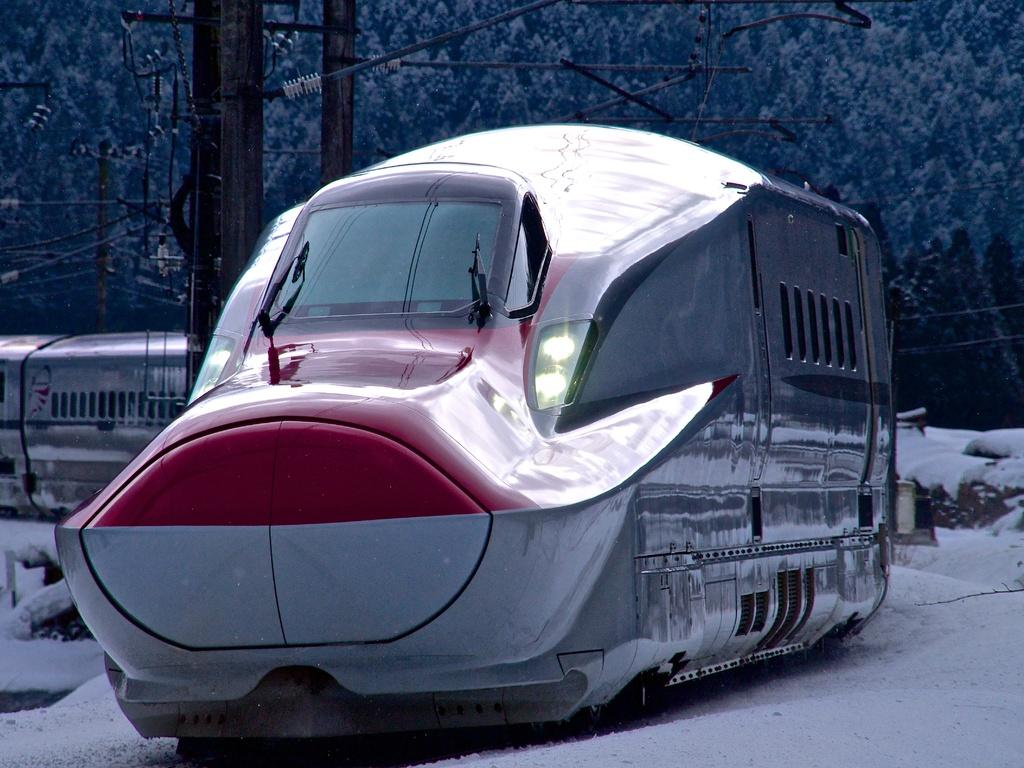What is the main subject in the center of the image? There is a train in the center of the image. What can be seen in the background of the image? There are poles, wires, snow, and trees visible in the background of the image. What type of pickle is being served on the train in the image? There is no pickle present in the image, as it features a train and background elements. How many bags of popcorn can be seen on the train in the image? There is no popcorn visible in the image; it only shows a train and background elements. 